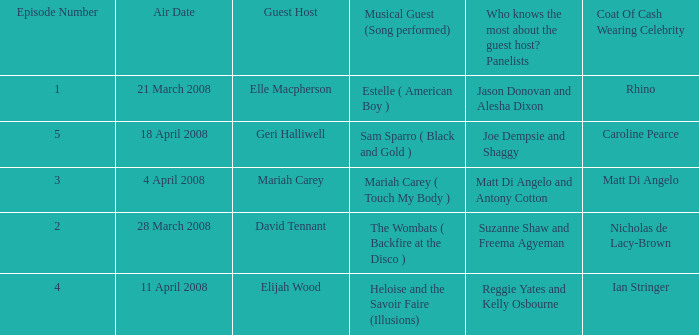Name the total number of episodes for coat of cash wearing celebrity is matt di angelo 1.0. 